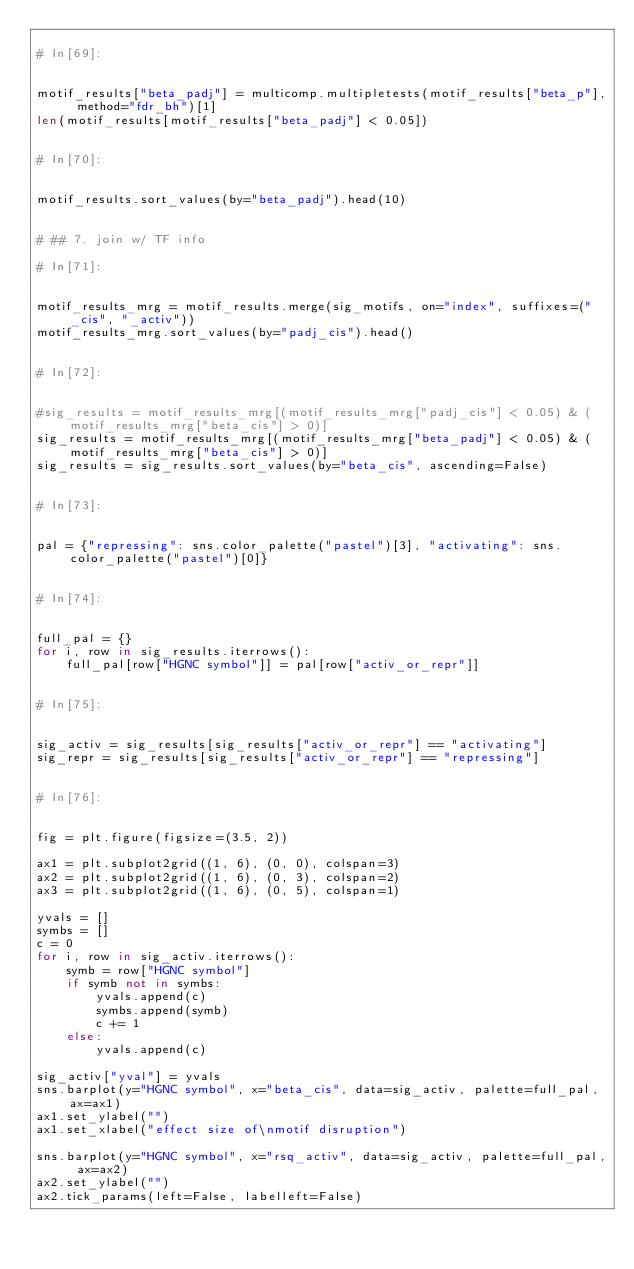Convert code to text. <code><loc_0><loc_0><loc_500><loc_500><_Python_>
# In[69]:


motif_results["beta_padj"] = multicomp.multipletests(motif_results["beta_p"], method="fdr_bh")[1]
len(motif_results[motif_results["beta_padj"] < 0.05])


# In[70]:


motif_results.sort_values(by="beta_padj").head(10)


# ## 7. join w/ TF info

# In[71]:


motif_results_mrg = motif_results.merge(sig_motifs, on="index", suffixes=("_cis", "_activ"))
motif_results_mrg.sort_values(by="padj_cis").head()


# In[72]:


#sig_results = motif_results_mrg[(motif_results_mrg["padj_cis"] < 0.05) & (motif_results_mrg["beta_cis"] > 0)]
sig_results = motif_results_mrg[(motif_results_mrg["beta_padj"] < 0.05) & (motif_results_mrg["beta_cis"] > 0)]
sig_results = sig_results.sort_values(by="beta_cis", ascending=False)


# In[73]:


pal = {"repressing": sns.color_palette("pastel")[3], "activating": sns.color_palette("pastel")[0]}


# In[74]:


full_pal = {}
for i, row in sig_results.iterrows():
    full_pal[row["HGNC symbol"]] = pal[row["activ_or_repr"]]


# In[75]:


sig_activ = sig_results[sig_results["activ_or_repr"] == "activating"]
sig_repr = sig_results[sig_results["activ_or_repr"] == "repressing"]


# In[76]:


fig = plt.figure(figsize=(3.5, 2))

ax1 = plt.subplot2grid((1, 6), (0, 0), colspan=3)
ax2 = plt.subplot2grid((1, 6), (0, 3), colspan=2)
ax3 = plt.subplot2grid((1, 6), (0, 5), colspan=1)

yvals = []
symbs = []
c = 0
for i, row in sig_activ.iterrows():
    symb = row["HGNC symbol"]
    if symb not in symbs:
        yvals.append(c)
        symbs.append(symb)
        c += 1
    else:
        yvals.append(c)

sig_activ["yval"] = yvals
sns.barplot(y="HGNC symbol", x="beta_cis", data=sig_activ, palette=full_pal, ax=ax1)
ax1.set_ylabel("")
ax1.set_xlabel("effect size of\nmotif disruption")

sns.barplot(y="HGNC symbol", x="rsq_activ", data=sig_activ, palette=full_pal, ax=ax2)
ax2.set_ylabel("")
ax2.tick_params(left=False, labelleft=False)</code> 